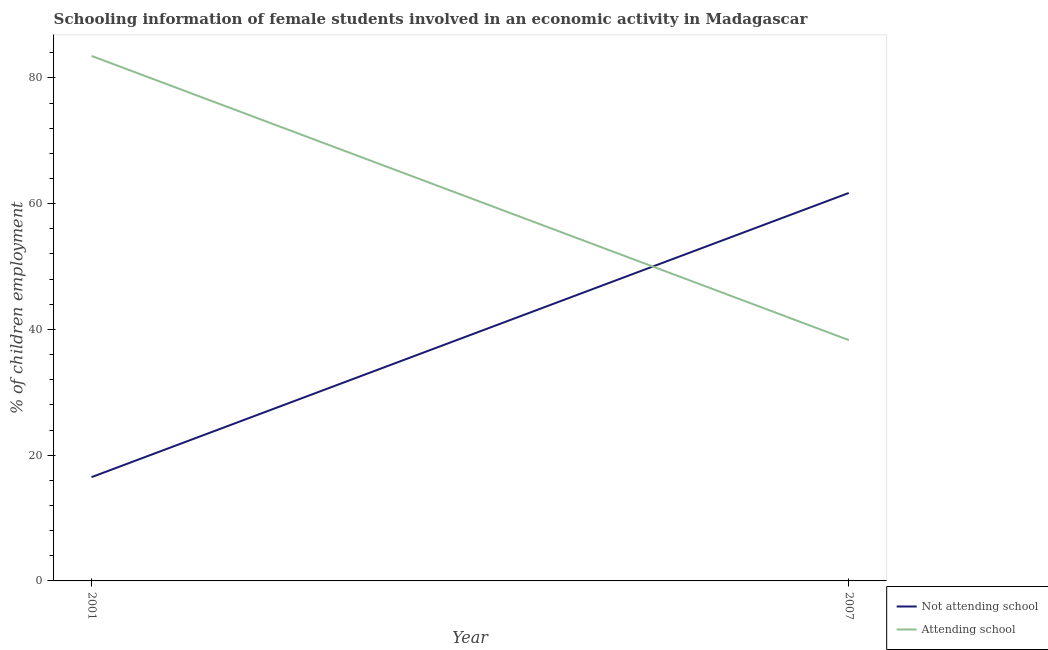How many different coloured lines are there?
Your answer should be compact. 2. Does the line corresponding to percentage of employed females who are attending school intersect with the line corresponding to percentage of employed females who are not attending school?
Offer a terse response. Yes. Is the number of lines equal to the number of legend labels?
Your answer should be very brief. Yes. What is the percentage of employed females who are attending school in 2007?
Make the answer very short. 38.3. Across all years, what is the maximum percentage of employed females who are not attending school?
Make the answer very short. 61.7. Across all years, what is the minimum percentage of employed females who are not attending school?
Offer a terse response. 16.51. In which year was the percentage of employed females who are attending school minimum?
Ensure brevity in your answer.  2007. What is the total percentage of employed females who are not attending school in the graph?
Your answer should be very brief. 78.21. What is the difference between the percentage of employed females who are attending school in 2001 and that in 2007?
Make the answer very short. 45.19. What is the difference between the percentage of employed females who are attending school in 2001 and the percentage of employed females who are not attending school in 2007?
Your response must be concise. 21.79. What is the average percentage of employed females who are attending school per year?
Offer a very short reply. 60.9. In the year 2007, what is the difference between the percentage of employed females who are attending school and percentage of employed females who are not attending school?
Offer a very short reply. -23.4. What is the ratio of the percentage of employed females who are attending school in 2001 to that in 2007?
Give a very brief answer. 2.18. Does the percentage of employed females who are attending school monotonically increase over the years?
Make the answer very short. No. Is the percentage of employed females who are not attending school strictly less than the percentage of employed females who are attending school over the years?
Keep it short and to the point. No. How many years are there in the graph?
Provide a succinct answer. 2. What is the difference between two consecutive major ticks on the Y-axis?
Your answer should be compact. 20. Are the values on the major ticks of Y-axis written in scientific E-notation?
Make the answer very short. No. Where does the legend appear in the graph?
Offer a terse response. Bottom right. How are the legend labels stacked?
Keep it short and to the point. Vertical. What is the title of the graph?
Keep it short and to the point. Schooling information of female students involved in an economic activity in Madagascar. What is the label or title of the X-axis?
Give a very brief answer. Year. What is the label or title of the Y-axis?
Make the answer very short. % of children employment. What is the % of children employment in Not attending school in 2001?
Your response must be concise. 16.51. What is the % of children employment in Attending school in 2001?
Make the answer very short. 83.49. What is the % of children employment of Not attending school in 2007?
Offer a terse response. 61.7. What is the % of children employment in Attending school in 2007?
Your answer should be very brief. 38.3. Across all years, what is the maximum % of children employment of Not attending school?
Make the answer very short. 61.7. Across all years, what is the maximum % of children employment of Attending school?
Offer a very short reply. 83.49. Across all years, what is the minimum % of children employment of Not attending school?
Provide a short and direct response. 16.51. Across all years, what is the minimum % of children employment in Attending school?
Ensure brevity in your answer.  38.3. What is the total % of children employment of Not attending school in the graph?
Offer a terse response. 78.21. What is the total % of children employment in Attending school in the graph?
Your answer should be compact. 121.79. What is the difference between the % of children employment in Not attending school in 2001 and that in 2007?
Provide a short and direct response. -45.19. What is the difference between the % of children employment in Attending school in 2001 and that in 2007?
Give a very brief answer. 45.19. What is the difference between the % of children employment of Not attending school in 2001 and the % of children employment of Attending school in 2007?
Offer a very short reply. -21.79. What is the average % of children employment in Not attending school per year?
Your response must be concise. 39.1. What is the average % of children employment of Attending school per year?
Give a very brief answer. 60.9. In the year 2001, what is the difference between the % of children employment in Not attending school and % of children employment in Attending school?
Ensure brevity in your answer.  -66.99. In the year 2007, what is the difference between the % of children employment of Not attending school and % of children employment of Attending school?
Provide a succinct answer. 23.4. What is the ratio of the % of children employment of Not attending school in 2001 to that in 2007?
Offer a very short reply. 0.27. What is the ratio of the % of children employment of Attending school in 2001 to that in 2007?
Make the answer very short. 2.18. What is the difference between the highest and the second highest % of children employment of Not attending school?
Provide a succinct answer. 45.19. What is the difference between the highest and the second highest % of children employment in Attending school?
Your answer should be compact. 45.19. What is the difference between the highest and the lowest % of children employment of Not attending school?
Offer a terse response. 45.19. What is the difference between the highest and the lowest % of children employment in Attending school?
Your answer should be very brief. 45.19. 